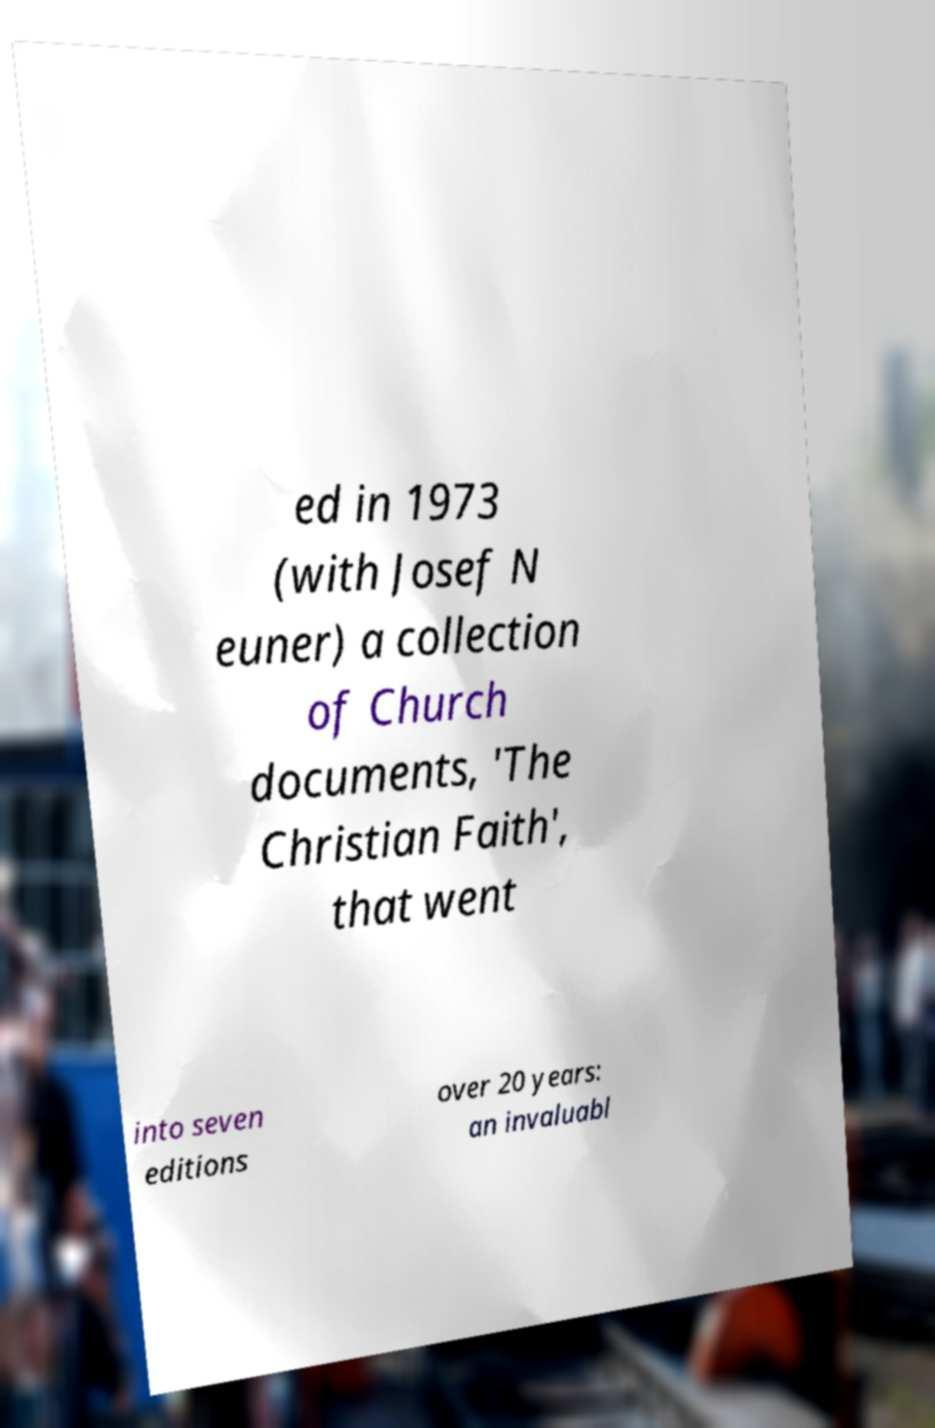Can you read and provide the text displayed in the image?This photo seems to have some interesting text. Can you extract and type it out for me? ed in 1973 (with Josef N euner) a collection of Church documents, 'The Christian Faith', that went into seven editions over 20 years: an invaluabl 